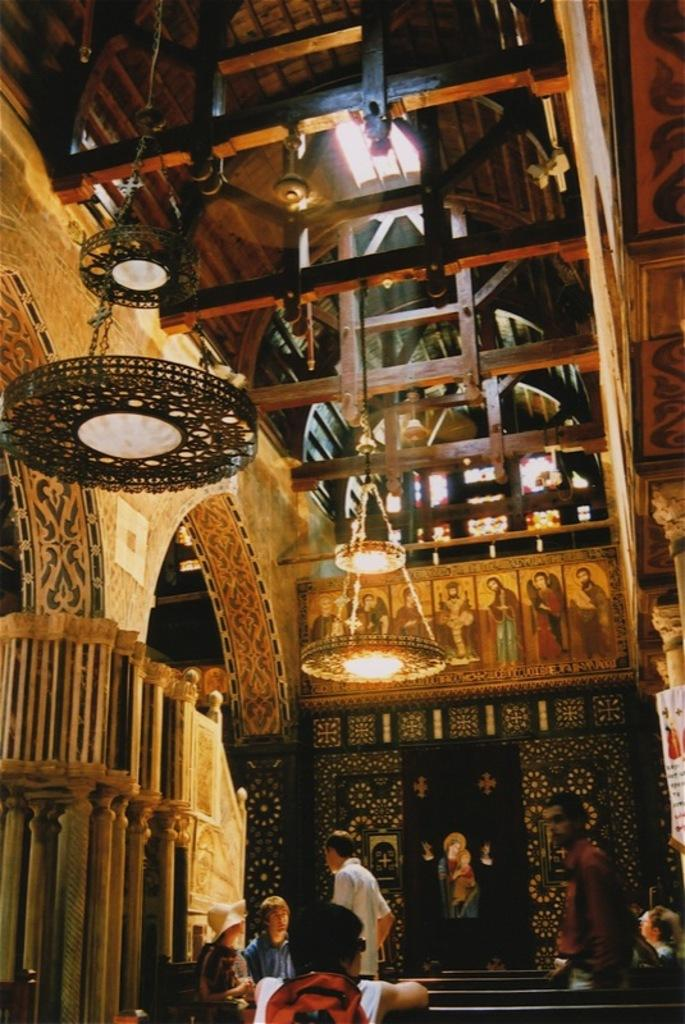How many people are in the image? There is a group of people in the image, but the exact number cannot be determined from the provided facts. What type of seating is available in the image? There are benches in the image. What else can be seen in the image besides the people and benches? There are objects in the image, but their specific nature cannot be determined from the provided facts. What is hanging at the top of the image? Lights are hanging at the top of the image. What type of slope can be seen in the image? There is no slope present in the image. How does the zephyr affect the people in the image? There is no mention of a zephyr or any wind in the image, so its effect on the people cannot be determined. 